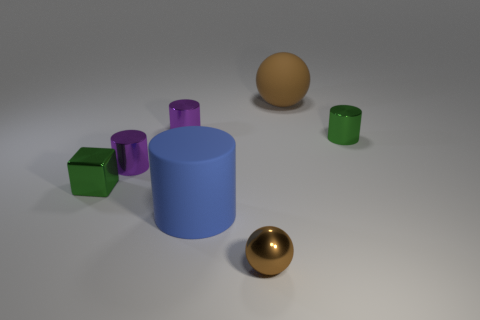How many other things are the same size as the brown rubber sphere?
Provide a short and direct response. 1. The cylinder that is the same color as the small shiny block is what size?
Make the answer very short. Small. What number of shiny things are the same color as the matte sphere?
Give a very brief answer. 1. What is the shape of the brown rubber thing?
Your answer should be compact. Sphere. The cylinder that is in front of the tiny green cylinder and on the left side of the blue matte object is what color?
Provide a succinct answer. Purple. What is the small brown ball made of?
Your answer should be compact. Metal. There is a metal object that is in front of the large cylinder; what shape is it?
Offer a terse response. Sphere. There is a metal cube that is the same size as the metal sphere; what is its color?
Make the answer very short. Green. Does the green object that is to the right of the large matte ball have the same material as the block?
Offer a terse response. Yes. What size is the object that is both behind the green metallic cylinder and right of the large rubber cylinder?
Ensure brevity in your answer.  Large. 